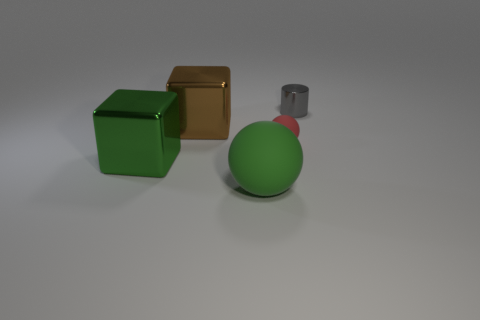Are there any green metallic objects that have the same shape as the large brown shiny thing?
Make the answer very short. Yes. The large metallic cube on the right side of the metal block in front of the red object is what color?
Your answer should be compact. Brown. Is the number of rubber objects greater than the number of red matte objects?
Provide a short and direct response. Yes. What number of other gray metal objects have the same size as the gray thing?
Your answer should be very brief. 0. Are the brown cube and the ball in front of the big green metal block made of the same material?
Give a very brief answer. No. Are there fewer tiny purple cylinders than tiny red spheres?
Keep it short and to the point. Yes. Is there anything else that has the same color as the large rubber object?
Ensure brevity in your answer.  Yes. What is the shape of the tiny red object that is made of the same material as the green sphere?
Offer a terse response. Sphere. There is a tiny thing that is in front of the small thing that is behind the brown metal block; how many big brown metallic things are on the right side of it?
Ensure brevity in your answer.  0. There is a thing that is both right of the large green matte ball and on the left side of the gray shiny cylinder; what shape is it?
Your answer should be compact. Sphere. 